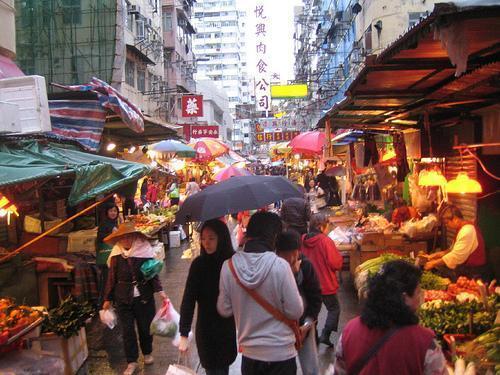How many people can be seen?
Give a very brief answer. 7. 